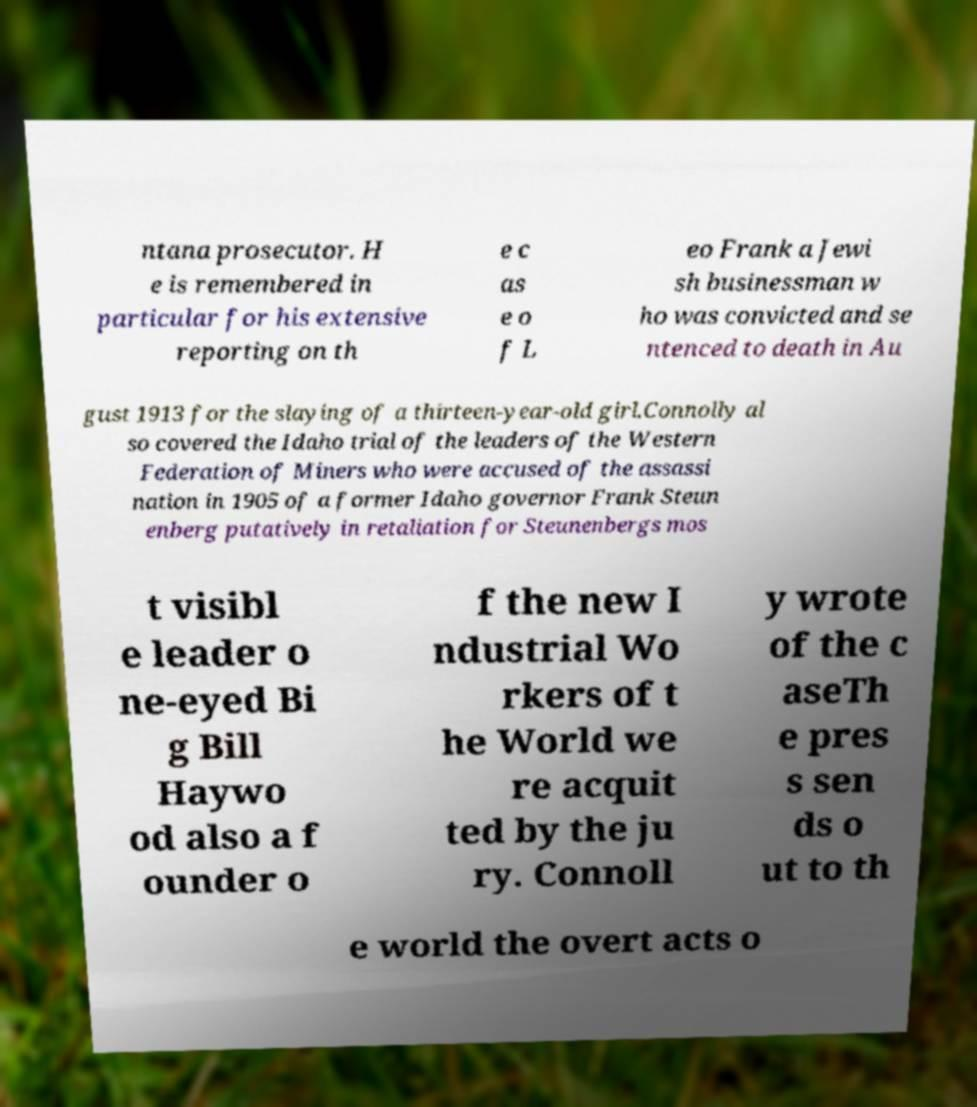For documentation purposes, I need the text within this image transcribed. Could you provide that? ntana prosecutor. H e is remembered in particular for his extensive reporting on th e c as e o f L eo Frank a Jewi sh businessman w ho was convicted and se ntenced to death in Au gust 1913 for the slaying of a thirteen-year-old girl.Connolly al so covered the Idaho trial of the leaders of the Western Federation of Miners who were accused of the assassi nation in 1905 of a former Idaho governor Frank Steun enberg putatively in retaliation for Steunenbergs mos t visibl e leader o ne-eyed Bi g Bill Haywo od also a f ounder o f the new I ndustrial Wo rkers of t he World we re acquit ted by the ju ry. Connoll y wrote of the c aseTh e pres s sen ds o ut to th e world the overt acts o 